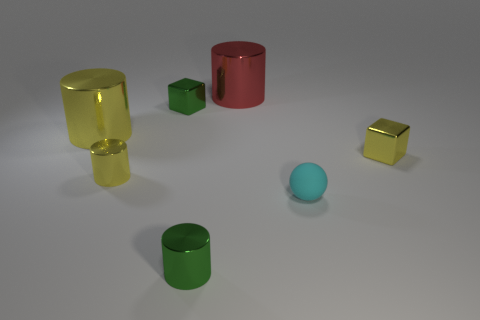Subtract all tiny yellow cylinders. How many cylinders are left? 3 Subtract all gray spheres. How many yellow cylinders are left? 2 Add 2 big red metallic cylinders. How many objects exist? 9 Subtract all green cylinders. How many cylinders are left? 3 Subtract 1 cylinders. How many cylinders are left? 3 Subtract all spheres. How many objects are left? 6 Subtract all large gray matte cylinders. Subtract all tiny metallic cylinders. How many objects are left? 5 Add 2 cyan objects. How many cyan objects are left? 3 Add 1 tiny balls. How many tiny balls exist? 2 Subtract 0 purple cylinders. How many objects are left? 7 